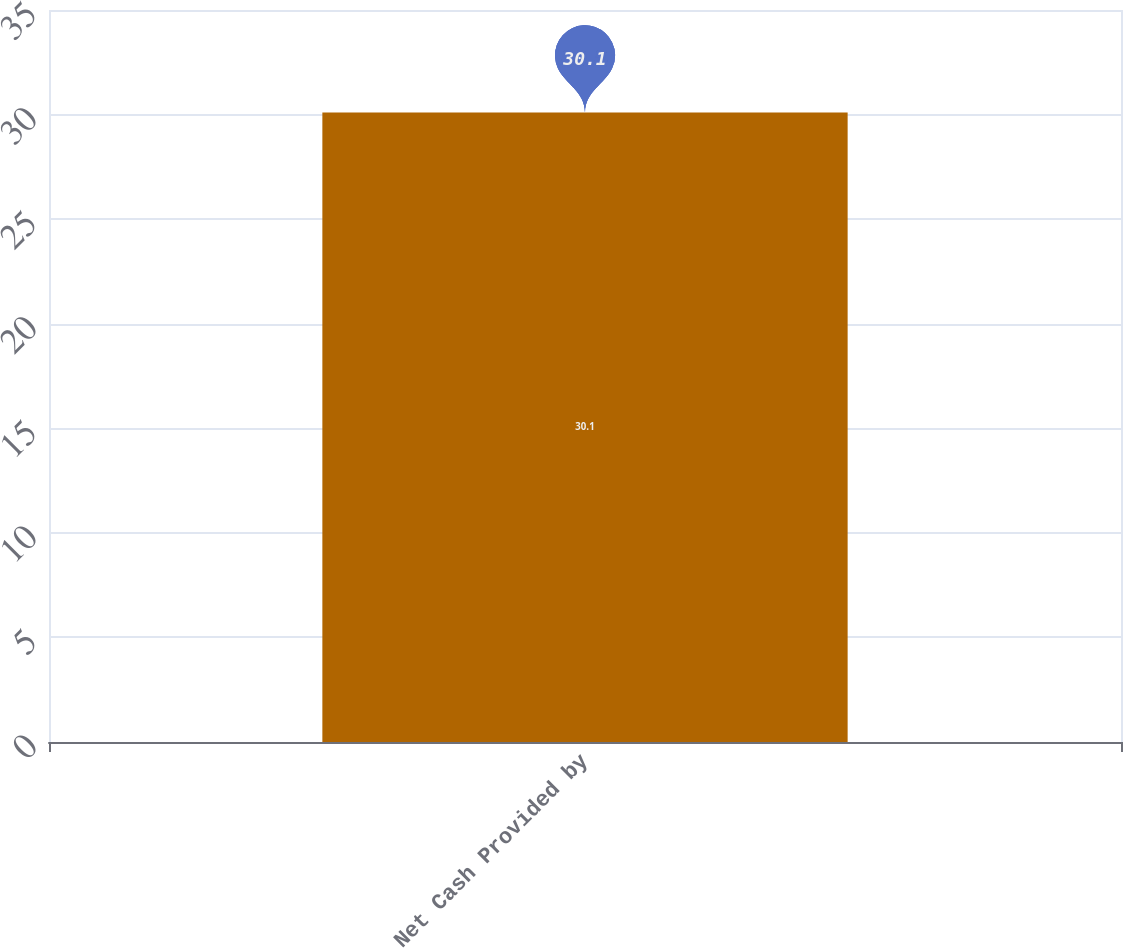Convert chart to OTSL. <chart><loc_0><loc_0><loc_500><loc_500><bar_chart><fcel>Net Cash Provided by<nl><fcel>30.1<nl></chart> 